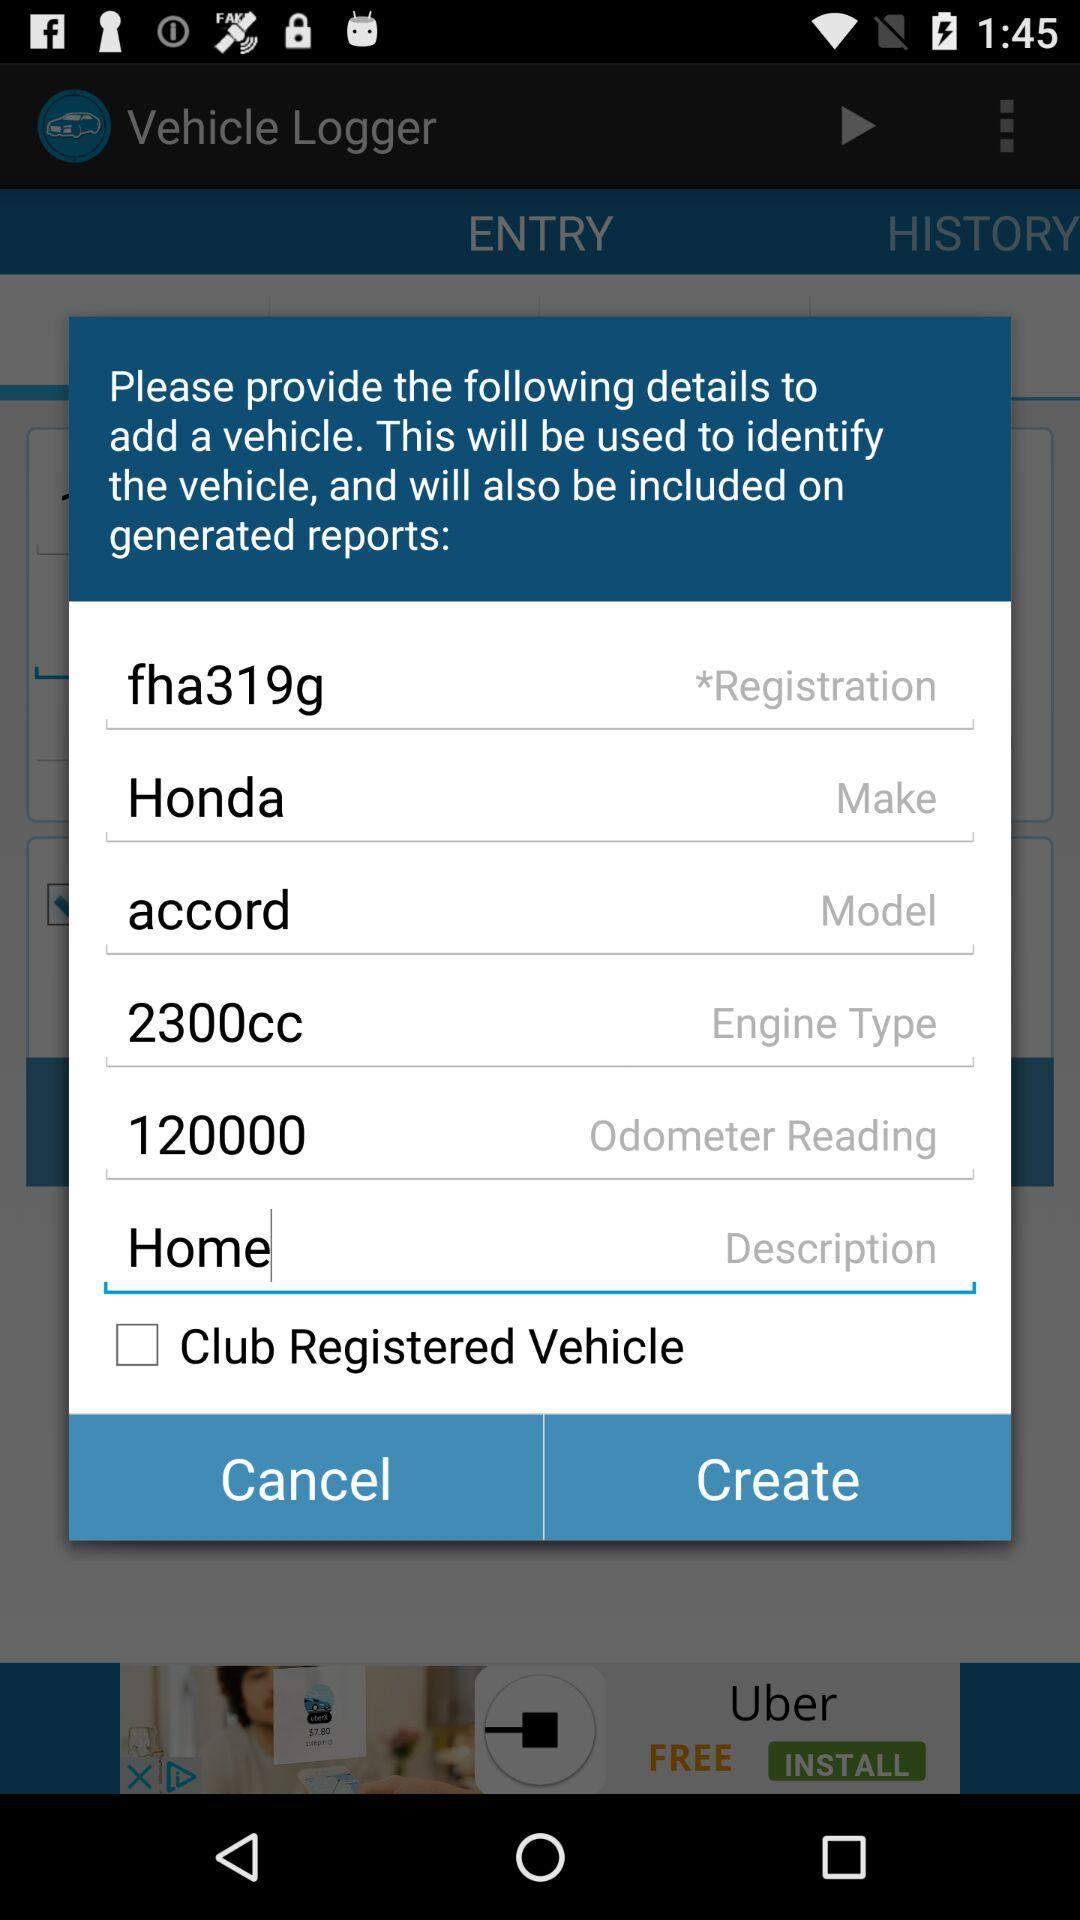What is the status of the "Club Registered Vehicle"? The status is "off". 